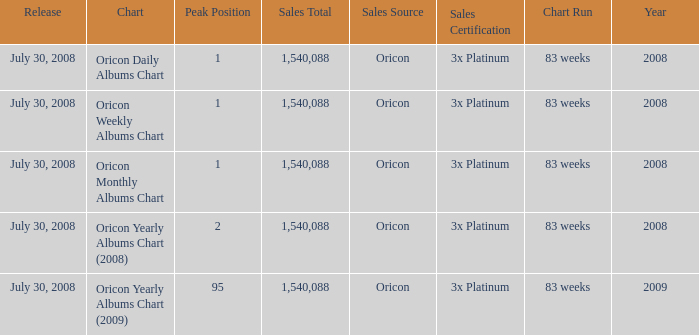Would you mind parsing the complete table? {'header': ['Release', 'Chart', 'Peak Position', 'Sales Total', 'Sales Source', 'Sales Certification', 'Chart Run', 'Year'], 'rows': [['July 30, 2008', 'Oricon Daily Albums Chart', '1', '1,540,088', 'Oricon', '3x Platinum', '83 weeks', '2008'], ['July 30, 2008', 'Oricon Weekly Albums Chart', '1', '1,540,088', 'Oricon', '3x Platinum', '83 weeks', '2008'], ['July 30, 2008', 'Oricon Monthly Albums Chart', '1', '1,540,088', 'Oricon', '3x Platinum', '83 weeks', '2008'], ['July 30, 2008', 'Oricon Yearly Albums Chart (2008)', '2', '1,540,088', 'Oricon', '3x Platinum', '83 weeks', '2008'], ['July 30, 2008', 'Oricon Yearly Albums Chart (2009)', '95', '1,540,088', 'Oricon', '3x Platinum', '83 weeks', '2009']]} How much Peak Position has Sales Total larger than 1,540,088? 0.0. 